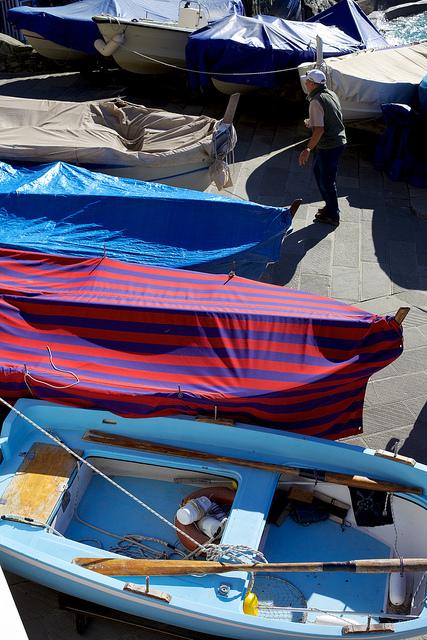How many boats is there?
Concise answer only. 6. Is that a young man?
Keep it brief. No. What is covering the boats?
Concise answer only. Tarps. 